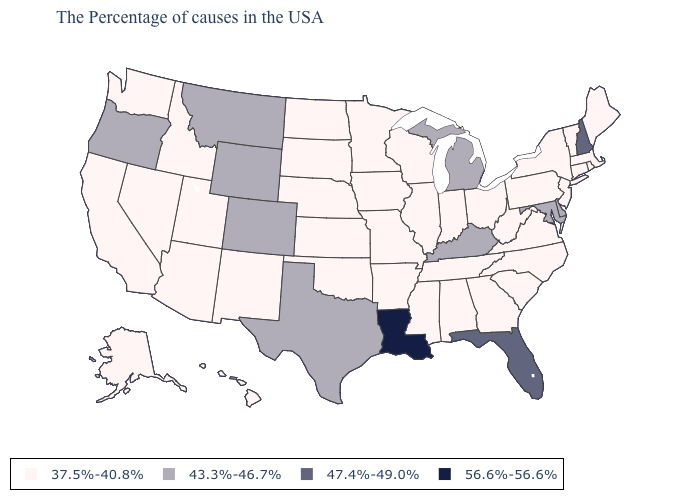Among the states that border Illinois , does Kentucky have the lowest value?
Keep it brief. No. Name the states that have a value in the range 37.5%-40.8%?
Quick response, please. Maine, Massachusetts, Rhode Island, Vermont, Connecticut, New York, New Jersey, Pennsylvania, Virginia, North Carolina, South Carolina, West Virginia, Ohio, Georgia, Indiana, Alabama, Tennessee, Wisconsin, Illinois, Mississippi, Missouri, Arkansas, Minnesota, Iowa, Kansas, Nebraska, Oklahoma, South Dakota, North Dakota, New Mexico, Utah, Arizona, Idaho, Nevada, California, Washington, Alaska, Hawaii. Name the states that have a value in the range 56.6%-56.6%?
Give a very brief answer. Louisiana. Does Vermont have the same value as Iowa?
Quick response, please. Yes. Name the states that have a value in the range 56.6%-56.6%?
Answer briefly. Louisiana. Does Missouri have the highest value in the MidWest?
Write a very short answer. No. Name the states that have a value in the range 56.6%-56.6%?
Short answer required. Louisiana. What is the value of South Carolina?
Keep it brief. 37.5%-40.8%. Does Alaska have a higher value than Iowa?
Be succinct. No. How many symbols are there in the legend?
Concise answer only. 4. What is the value of Arizona?
Quick response, please. 37.5%-40.8%. What is the value of New Mexico?
Concise answer only. 37.5%-40.8%. What is the lowest value in the USA?
Concise answer only. 37.5%-40.8%. 